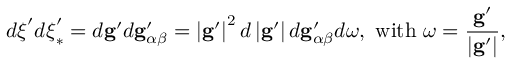<formula> <loc_0><loc_0><loc_500><loc_500>d \xi ^ { \prime } d \xi _ { \ast } ^ { \prime } = d g ^ { \prime } d g _ { \alpha \beta } ^ { \prime } = \left | g ^ { \prime } \right | ^ { 2 } d \left | g ^ { \prime } \right | d g _ { \alpha \beta } ^ { \prime } d \omega , w i t h \ \omega = \frac { g ^ { \prime } } { \left | g ^ { \prime } \right | } ,</formula> 